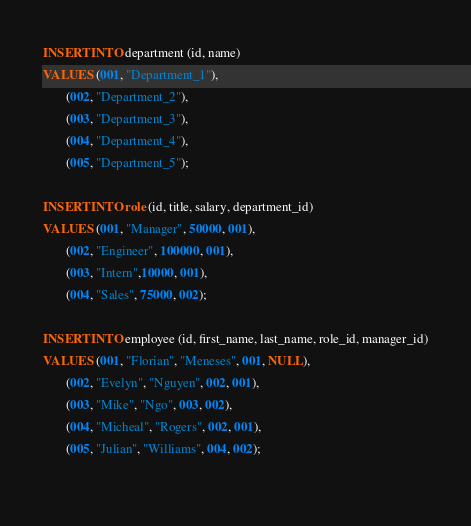<code> <loc_0><loc_0><loc_500><loc_500><_SQL_>INSERT INTO department (id, name)
VALUES (001, "Department_1"),
       (002, "Department_2"),
       (003, "Department_3"),
       (004, "Department_4"),
       (005, "Department_5");

INSERT INTO role (id, title, salary, department_id)
VALUES (001, "Manager", 50000, 001),
       (002, "Engineer", 100000, 001),
       (003, "Intern",10000, 001),
       (004, "Sales", 75000, 002);

INSERT INTO employee (id, first_name, last_name, role_id, manager_id)
VALUES (001, "Florian", "Meneses", 001, NULL),
       (002, "Evelyn", "Nguyen", 002, 001),
       (003, "Mike", "Ngo", 003, 002),
       (004, "Micheal", "Rogers", 002, 001),
       (005, "Julian", "Williams", 004, 002);
       </code> 